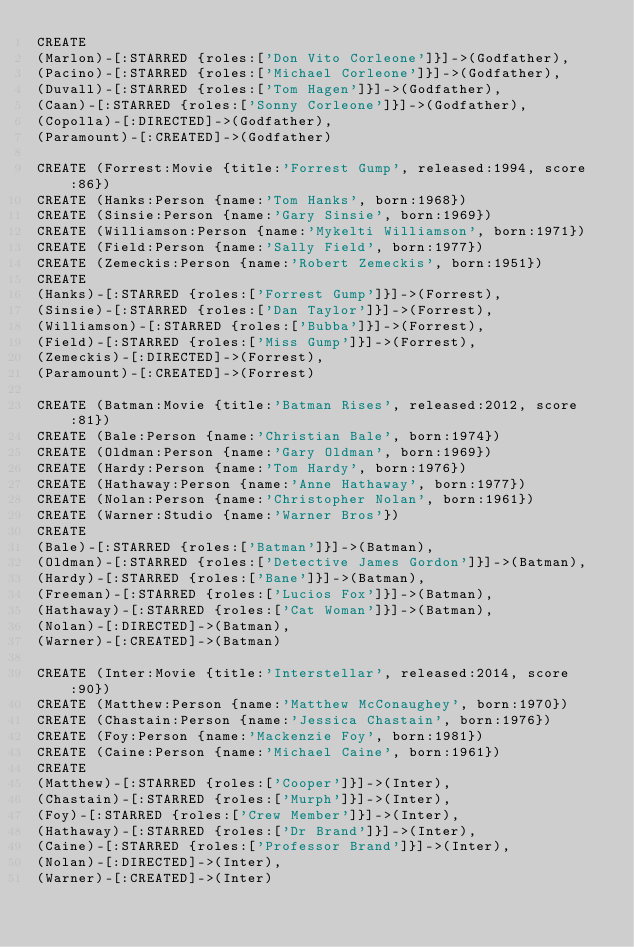<code> <loc_0><loc_0><loc_500><loc_500><_SQL_>CREATE
(Marlon)-[:STARRED {roles:['Don Vito Corleone']}]->(Godfather),
(Pacino)-[:STARRED {roles:['Michael Corleone']}]->(Godfather),
(Duvall)-[:STARRED {roles:['Tom Hagen']}]->(Godfather),
(Caan)-[:STARRED {roles:['Sonny Corleone']}]->(Godfather),
(Copolla)-[:DIRECTED]->(Godfather),
(Paramount)-[:CREATED]->(Godfather)

CREATE (Forrest:Movie {title:'Forrest Gump', released:1994, score:86})
CREATE (Hanks:Person {name:'Tom Hanks', born:1968})
CREATE (Sinsie:Person {name:'Gary Sinsie', born:1969})
CREATE (Williamson:Person {name:'Mykelti Williamson', born:1971})
CREATE (Field:Person {name:'Sally Field', born:1977})
CREATE (Zemeckis:Person {name:'Robert Zemeckis', born:1951})
CREATE
(Hanks)-[:STARRED {roles:['Forrest Gump']}]->(Forrest),
(Sinsie)-[:STARRED {roles:['Dan Taylor']}]->(Forrest),
(Williamson)-[:STARRED {roles:['Bubba']}]->(Forrest),
(Field)-[:STARRED {roles:['Miss Gump']}]->(Forrest),
(Zemeckis)-[:DIRECTED]->(Forrest),
(Paramount)-[:CREATED]->(Forrest)

CREATE (Batman:Movie {title:'Batman Rises', released:2012, score:81})
CREATE (Bale:Person {name:'Christian Bale', born:1974})
CREATE (Oldman:Person {name:'Gary Oldman', born:1969})
CREATE (Hardy:Person {name:'Tom Hardy', born:1976})
CREATE (Hathaway:Person {name:'Anne Hathaway', born:1977})
CREATE (Nolan:Person {name:'Christopher Nolan', born:1961})
CREATE (Warner:Studio {name:'Warner Bros'})
CREATE
(Bale)-[:STARRED {roles:['Batman']}]->(Batman),
(Oldman)-[:STARRED {roles:['Detective James Gordon']}]->(Batman),
(Hardy)-[:STARRED {roles:['Bane']}]->(Batman),
(Freeman)-[:STARRED {roles:['Lucios Fox']}]->(Batman),
(Hathaway)-[:STARRED {roles:['Cat Woman']}]->(Batman),
(Nolan)-[:DIRECTED]->(Batman),
(Warner)-[:CREATED]->(Batman)

CREATE (Inter:Movie {title:'Interstellar', released:2014, score:90})
CREATE (Matthew:Person {name:'Matthew McConaughey', born:1970})
CREATE (Chastain:Person {name:'Jessica Chastain', born:1976})
CREATE (Foy:Person {name:'Mackenzie Foy', born:1981})
CREATE (Caine:Person {name:'Michael Caine', born:1961})
CREATE
(Matthew)-[:STARRED {roles:['Cooper']}]->(Inter),
(Chastain)-[:STARRED {roles:['Murph']}]->(Inter),
(Foy)-[:STARRED {roles:['Crew Member']}]->(Inter),
(Hathaway)-[:STARRED {roles:['Dr Brand']}]->(Inter),
(Caine)-[:STARRED {roles:['Professor Brand']}]->(Inter),
(Nolan)-[:DIRECTED]->(Inter),
(Warner)-[:CREATED]->(Inter)
</code> 